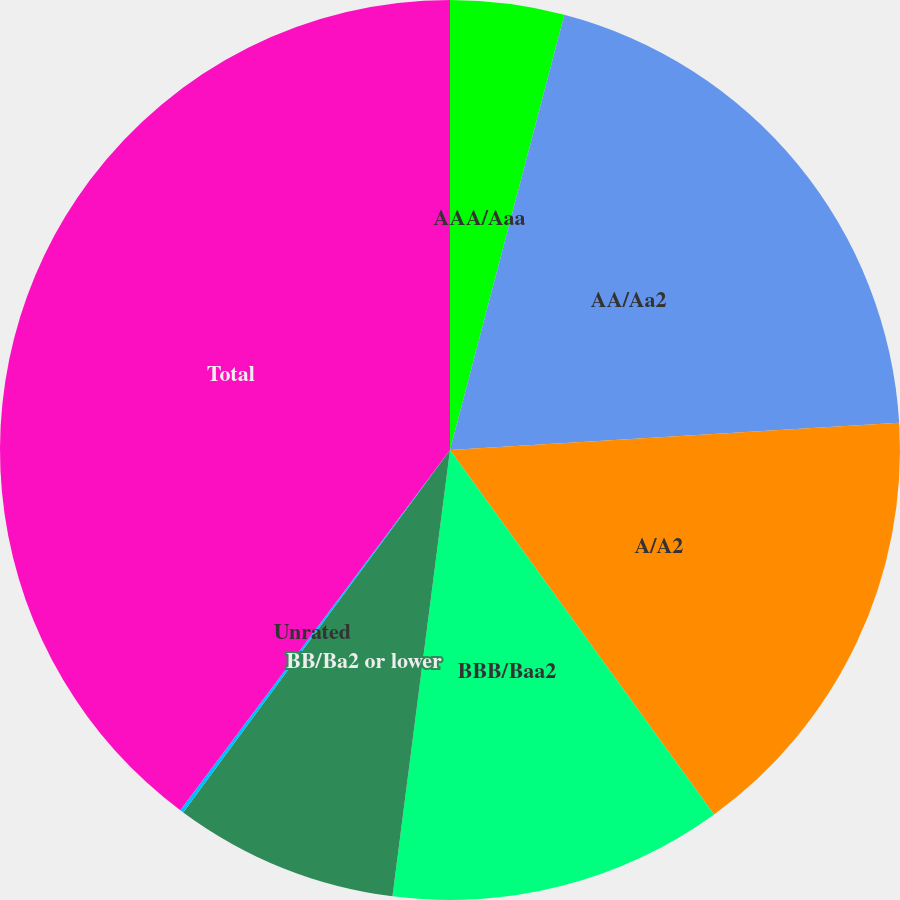Convert chart to OTSL. <chart><loc_0><loc_0><loc_500><loc_500><pie_chart><fcel>AAA/Aaa<fcel>AA/Aa2<fcel>A/A2<fcel>BBB/Baa2<fcel>BB/Ba2 or lower<fcel>Unrated<fcel>Total<nl><fcel>4.09%<fcel>19.95%<fcel>15.98%<fcel>12.02%<fcel>8.06%<fcel>0.13%<fcel>39.77%<nl></chart> 